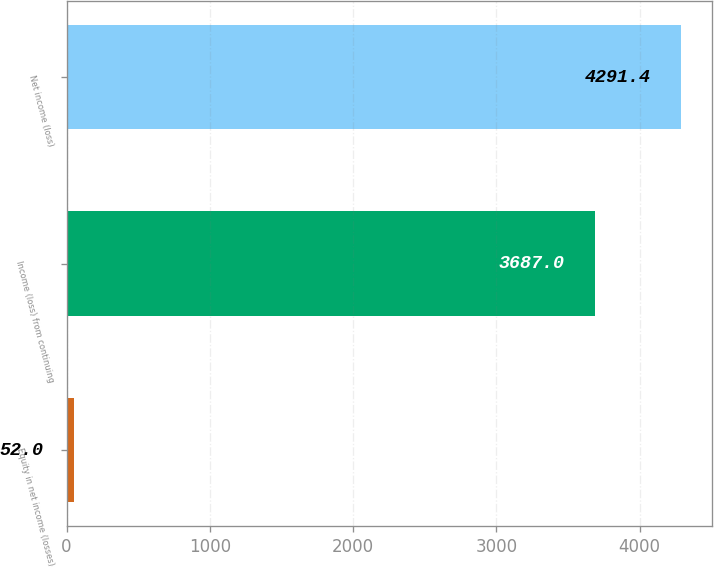Convert chart to OTSL. <chart><loc_0><loc_0><loc_500><loc_500><bar_chart><fcel>Equity in net income (losses)<fcel>Income (loss) from continuing<fcel>Net income (loss)<nl><fcel>52<fcel>3687<fcel>4291.4<nl></chart> 